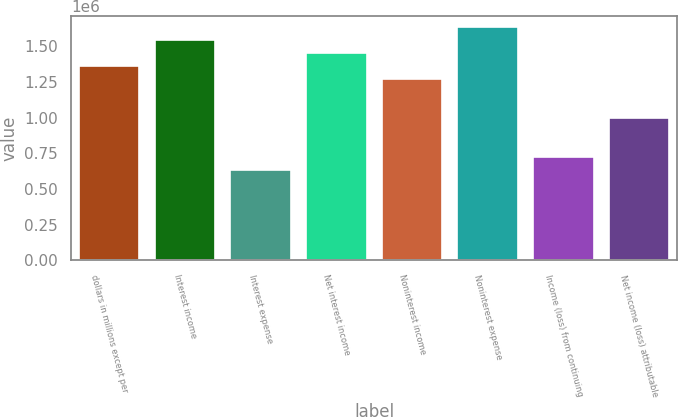Convert chart to OTSL. <chart><loc_0><loc_0><loc_500><loc_500><bar_chart><fcel>dollars in millions except per<fcel>Interest income<fcel>Interest expense<fcel>Net interest income<fcel>Noninterest income<fcel>Noninterest expense<fcel>Income (loss) from continuing<fcel>Net income (loss) attributable<nl><fcel>1.35979e+06<fcel>1.54109e+06<fcel>634567<fcel>1.45044e+06<fcel>1.26913e+06<fcel>1.63174e+06<fcel>725219<fcel>997176<nl></chart> 